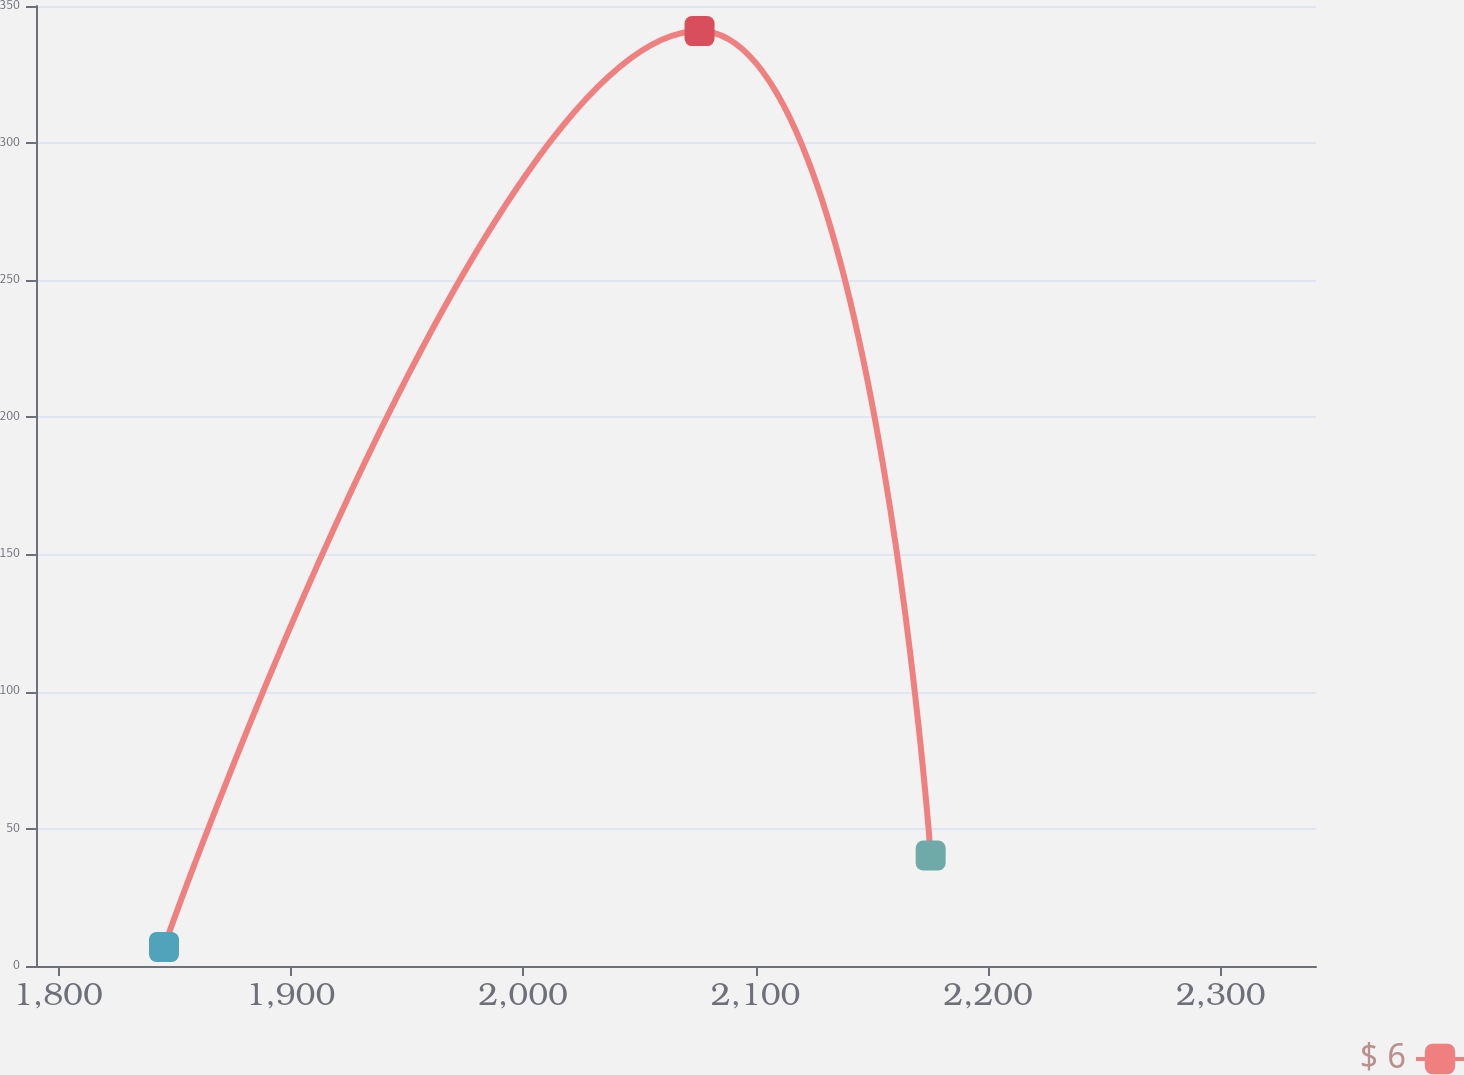Convert chart. <chart><loc_0><loc_0><loc_500><loc_500><line_chart><ecel><fcel>$ 6<nl><fcel>1845.61<fcel>6.91<nl><fcel>2075.9<fcel>340.84<nl><fcel>2175.28<fcel>40.3<nl><fcel>2396.01<fcel>288.31<nl></chart> 